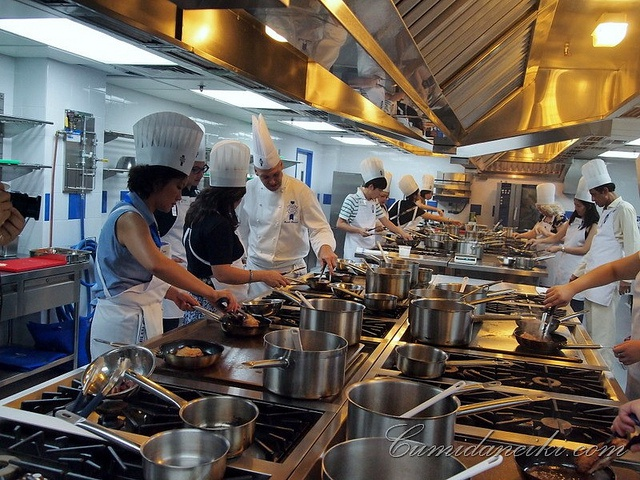Describe the objects in this image and their specific colors. I can see oven in gray, black, maroon, and darkgray tones, oven in gray, black, and maroon tones, people in gray, black, and darkgray tones, people in gray, darkgray, and tan tones, and people in gray, black, darkgray, and maroon tones in this image. 